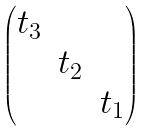Convert formula to latex. <formula><loc_0><loc_0><loc_500><loc_500>\begin{pmatrix} t _ { 3 } & & \\ & t _ { 2 } & \\ & & t _ { 1 } \end{pmatrix}</formula> 